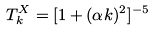Convert formula to latex. <formula><loc_0><loc_0><loc_500><loc_500>T _ { k } ^ { X } = [ 1 + ( \alpha k ) ^ { 2 } ] ^ { - 5 }</formula> 